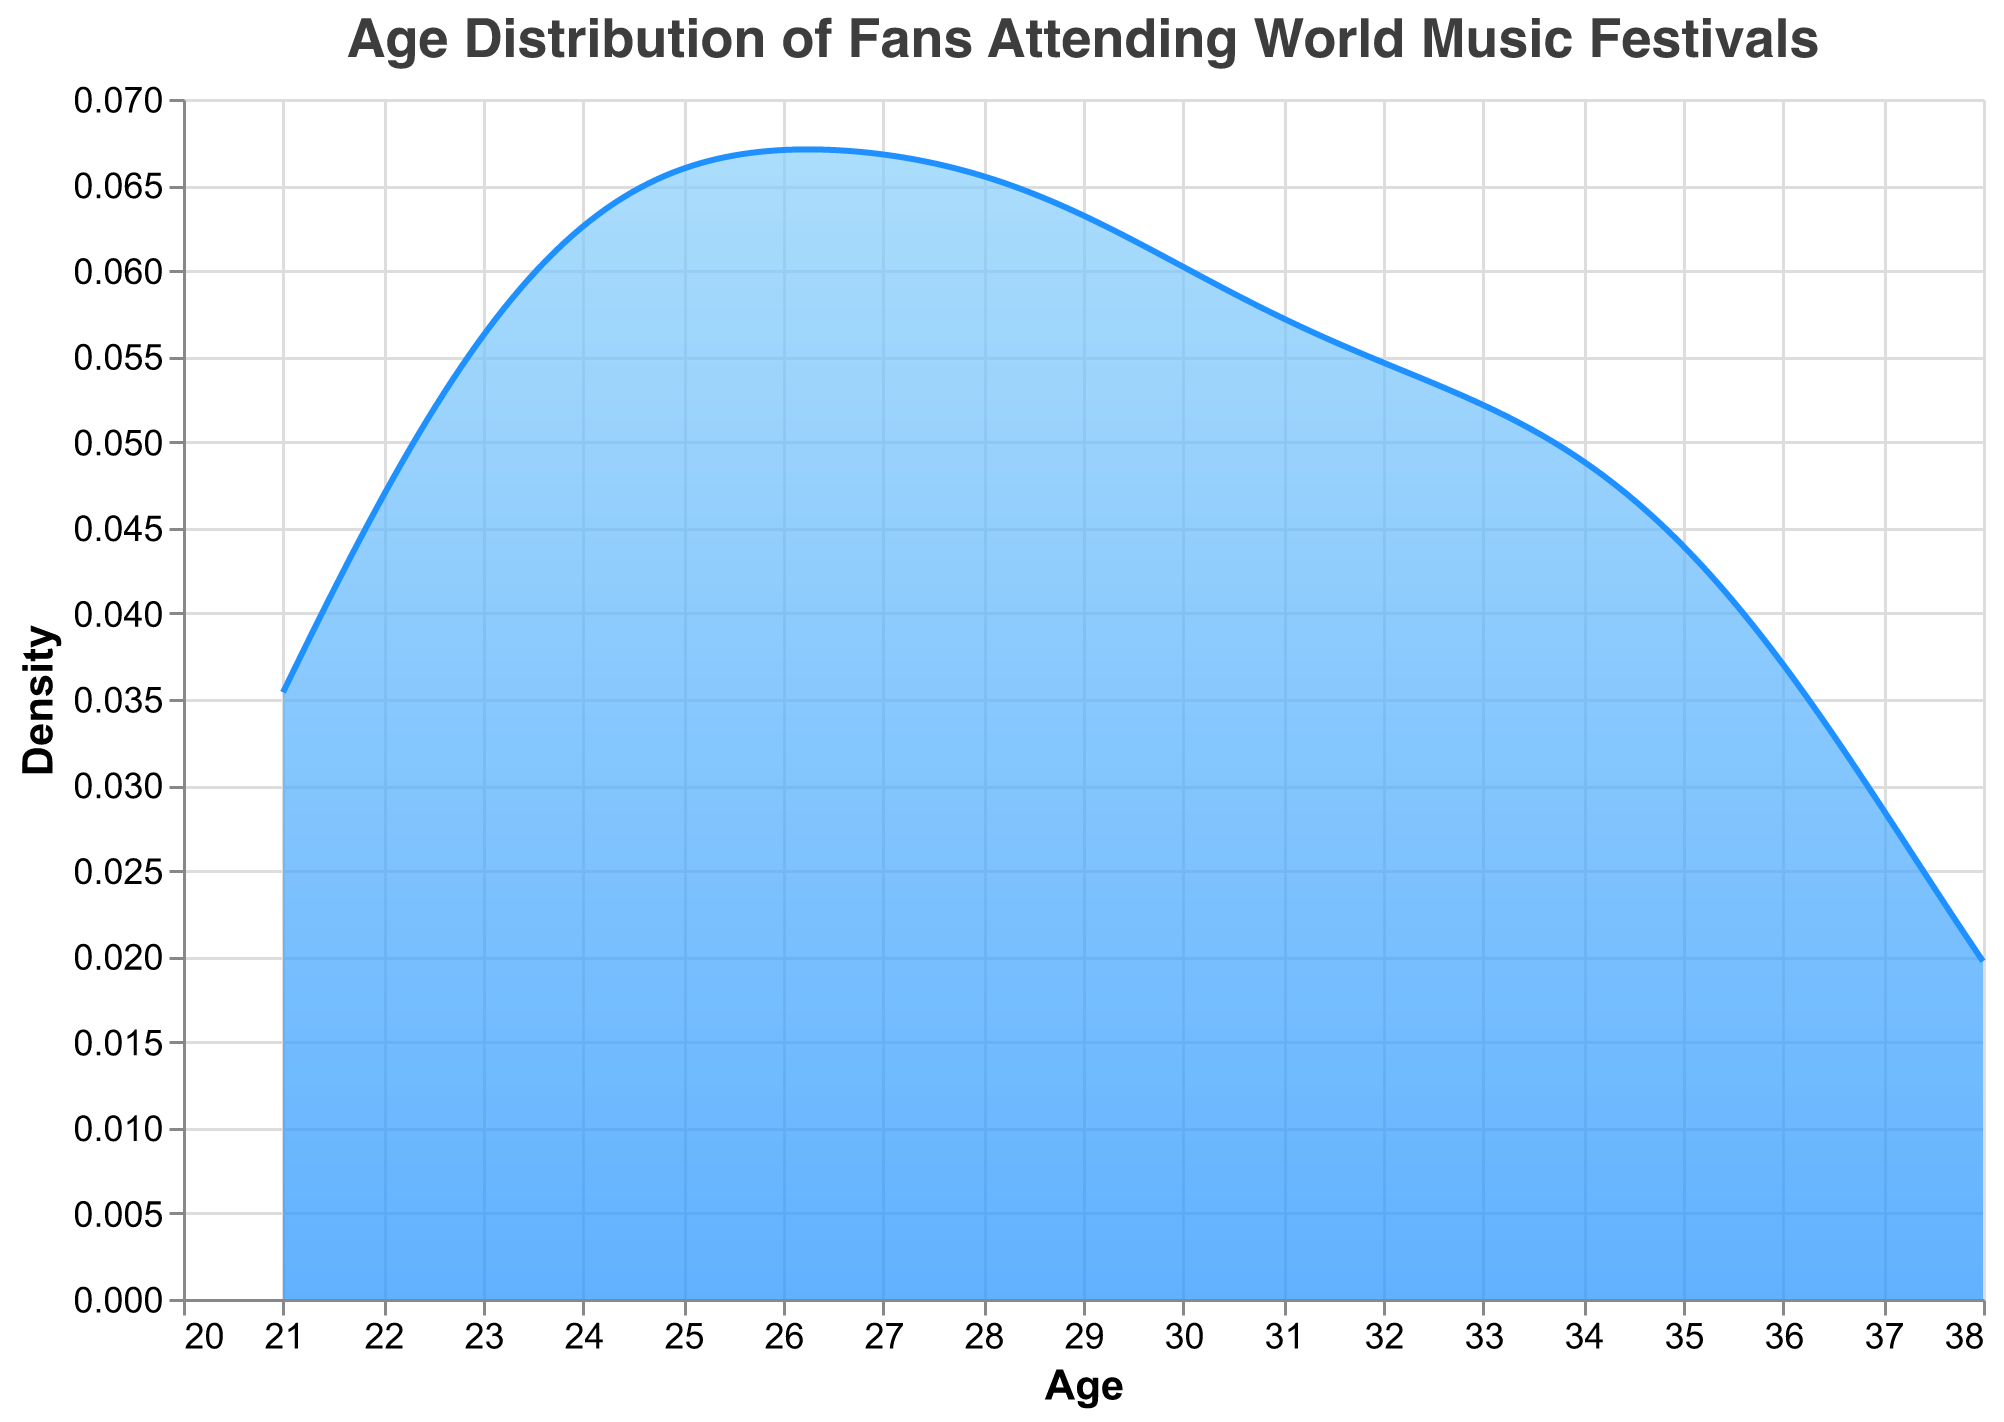What is the title of the figure? The title is usually located at the top of the figure. It provides a summary of what the visual is about. In this case, the title is "Age Distribution of Fans Attending World Music Festivals".
Answer: Age Distribution of Fans Attending World Music Festivals What are the labels on the x and y axes? The labels for the axes are typically indicated directly next to or on the axes themselves. The x-axis is labeled "Age," and the y-axis is labeled "Density."
Answer: Age; Density What does the peak in the density curve represent? The peak in the density curve represents the age range where there is the highest concentration of fans attending world music festivals.
Answer: The most common age range of fans What age range appears to have the highest density of festival fans? To find the age range with the highest density, look for the peak of the density curve on the x-axis. The age range around 23-26 seems to have the highest density of fans.
Answer: 23-26 years Which age range has the least density of fans? The lowest points on the density curve on the x-axis can indicate the age range with the least density of fans. This occurs towards the extremes (youngest and oldest), particularly around 21 and 38 years.
Answer: 21 and 38 years How does the density of fans aged 25 compare to those aged 30? To compare, look at the density values (y-axis) at ages 25 and 30 (x-axis). The density is higher at age 25 than at age 30.
Answer: Higher at age 25 What's the average age of fans attending the festivals? To find the average, consider the overall spread and peak concentration areas. The average can be approximated around the central values where density peaks. The average appears to be around 28 years.
Answer: Around 28 years Are there more fans above age 30 or below age 30? To determine this, compare the area under the density curve for ages above and below 30. More fans are below age 30 as the density is higher and more spread out below 30.
Answer: More fans below age 30 